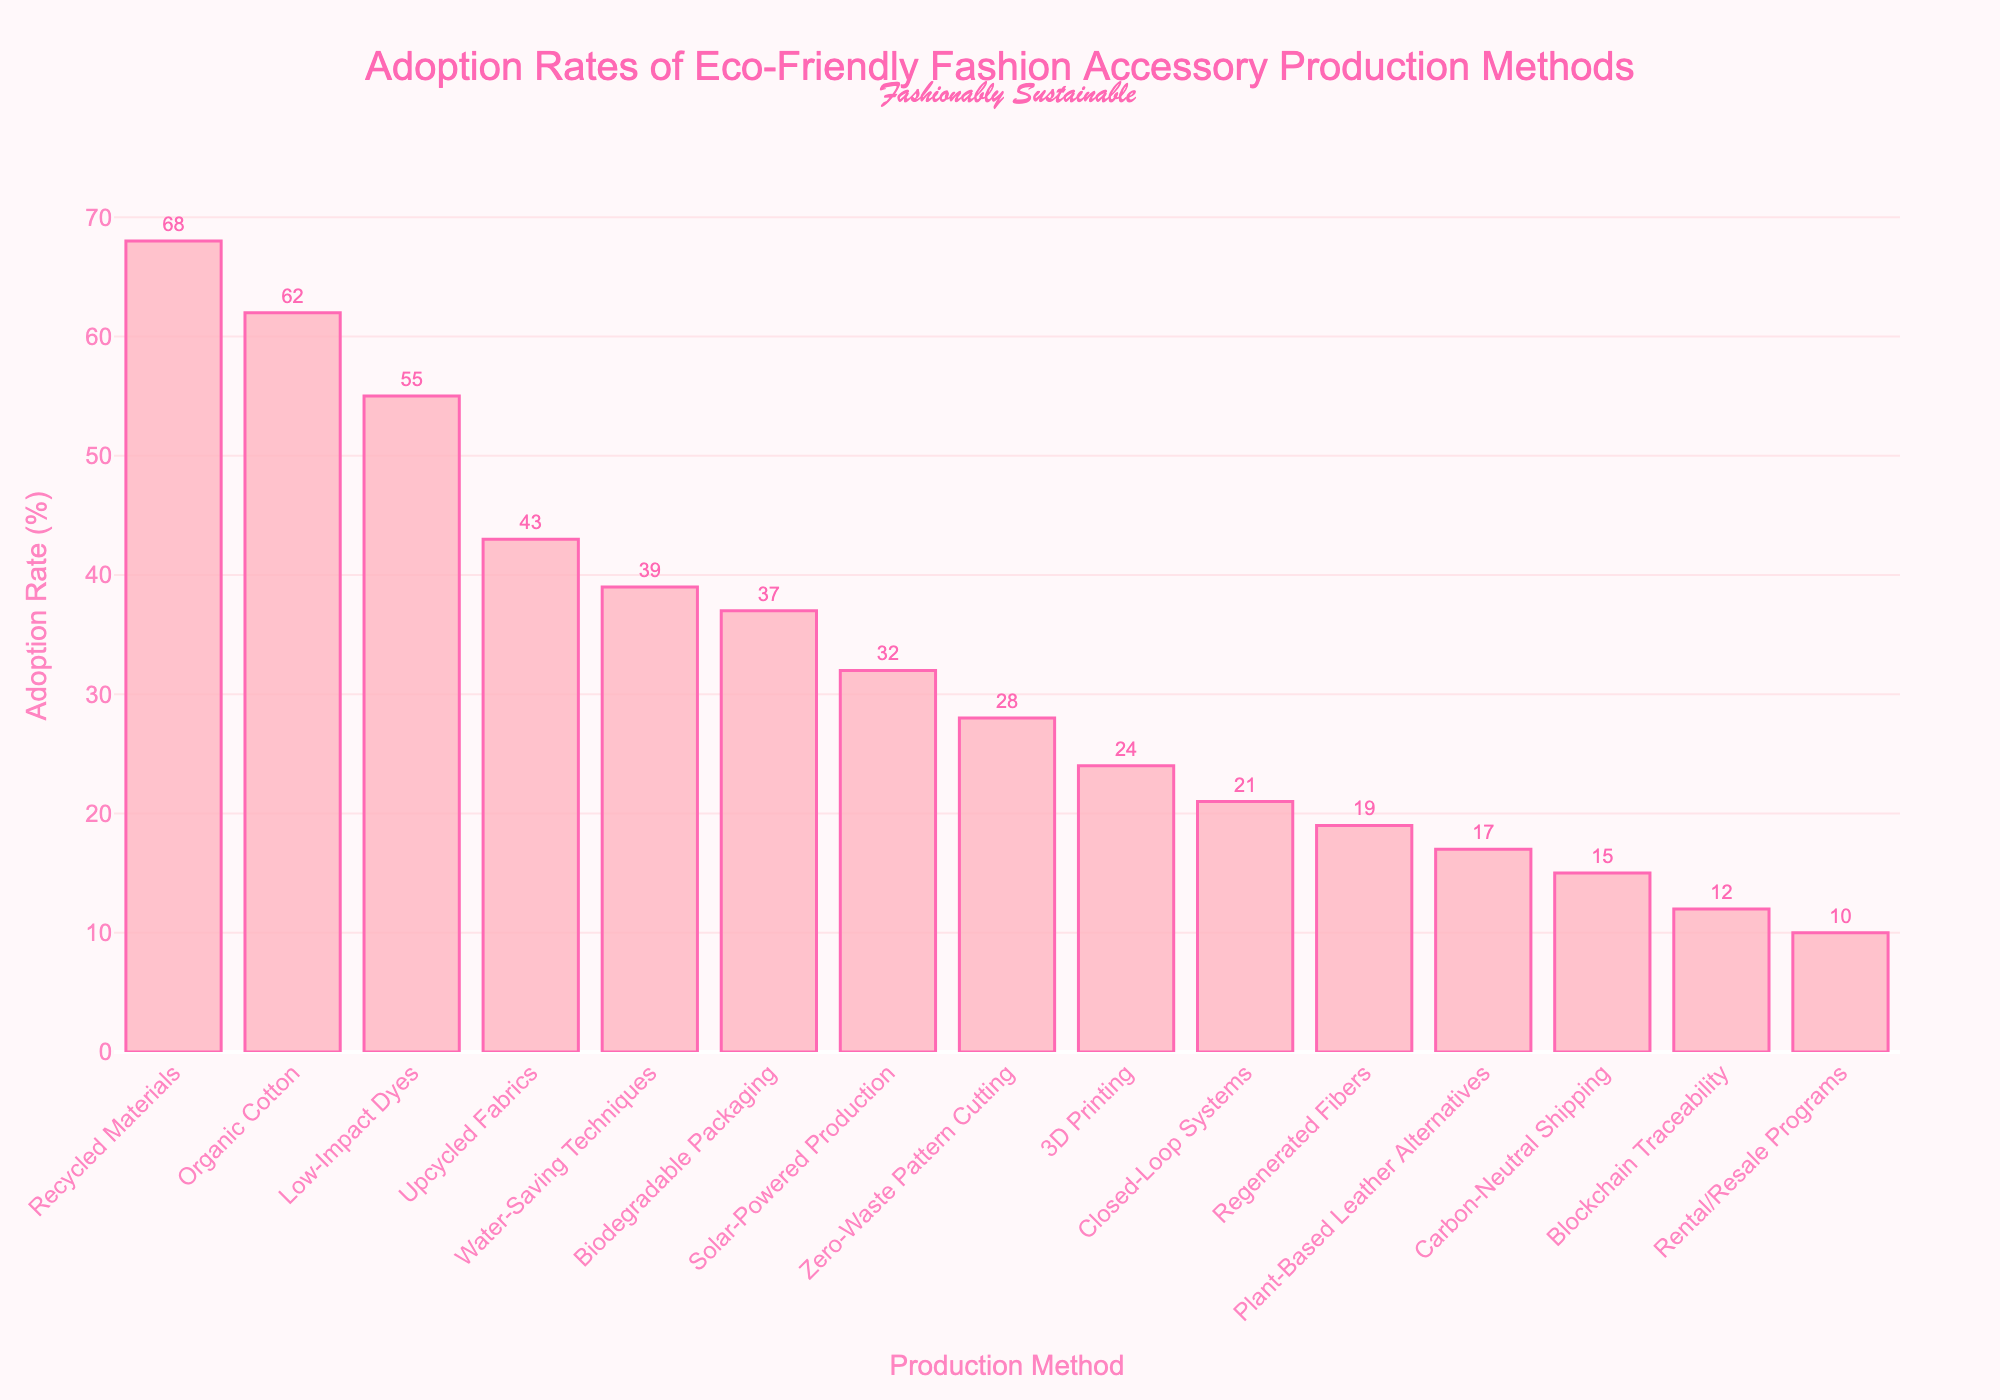What's the highest adoption rate among the eco-friendly fashion production methods? The highest adoption rate can be identified by looking at the tallest bar in the chart. The bar representing "Recycled Materials" is the tallest, with an adoption rate of 68%.
Answer: 68% Which two methods have adoption rates closest to each other? Looking at the chart, "Organic Cotton" with an adoption rate of 62% and "Low-Impact Dyes" with an adoption rate of 55% have the closest values among the listed methods.
Answer: Organic Cotton and Low-Impact Dyes What is the combined adoption rate of the top three methods? The top three methods by adoption rate are "Recycled Materials" (68%), "Organic Cotton" (62%), and "Low-Impact Dyes" (55%). Adding these together, 68 + 62 + 55 = 185%.
Answer: 185% Which method has an adoption rate that is more than 40% but less than 50%? The bar representing "Upcycled Fabrics" shows an adoption rate of 43%, which fits the specified criteria of more than 40% and less than 50%.
Answer: Upcycled Fabrics What is the median adoption rate for all methods listed? First, list all adoption rates in ascending order: 10, 12, 15, 17, 19, 21, 24, 28, 32, 37, 39, 43, 55, 62, 68. With 15 data points, the median is the 8th value. Counting from the beginning, the 8th value is "28%".
Answer: 28% Which methods have an adoption rate lower than 20%? Looking at the bars with heights representing values lower than 20%, the methods are "Regenerated Fibers" (19%), "Plant-Based Leather Alternatives" (17%), "Carbon-Neutral Shipping" (15%), "Blockchain Traceability" (12%), and "Rental/Resale Programs" (10%).
Answer: Regenerated Fibers, Plant-Based Leather Alternatives, Carbon-Neutral Shipping, Blockchain Traceability, Rental/Resale Programs How much higher is the adoption rate of "Recycled Materials" compared to "Biodegradable Packaging"? "Recycled Materials" has an adoption rate of 68%, while "Biodegradable Packaging" has 37%. The difference is 68 - 37 = 31%.
Answer: 31% Which method has the least adoption rate and what is it? The shortest bar in the chart represents the method with the least adoption rate, which is "Rental/Resale Programs" at 10%.
Answer: Rental/Resale Programs, 10% What is the average adoption rate of methods with adoption rates above 50%? The methods with adoption rates above 50% are "Recycled Materials" (68%), "Organic Cotton" (62%), and "Low-Impact Dyes" (55%). The average is calculated as (68 + 62 + 55) / 3 = 185 / 3 ≈ 61.67%.
Answer: 61.67% How does the adoption rate of "Zero-Waste Pattern Cutting" compare to "Closed-Loop Systems"? "Zero-Waste Pattern Cutting" has an adoption rate of 28%, whereas "Closed-Loop Systems" has 21%. Thus, "Zero-Waste Pattern Cutting" has a higher adoption rate by 28 - 21 = 7%.
Answer: 7% 